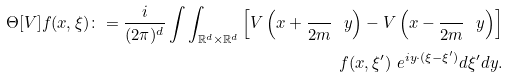Convert formula to latex. <formula><loc_0><loc_0><loc_500><loc_500>\Theta [ V ] f ( x , \xi ) \colon = \frac { i } { ( 2 \pi ) ^ { d } } \int \int _ { \mathbb { R } ^ { d } \times \mathbb { R } ^ { d } } \left [ V \left ( { x + \frac { } { 2 m } \ y } \right ) - V \left ( { x - \frac { } { 2 m } \ y } \right ) \right ] \\ f ( x , \xi ^ { \prime } ) \ e ^ { i y \cdot ( \xi - \xi ^ { \prime } ) } d \xi ^ { \prime } d y .</formula> 